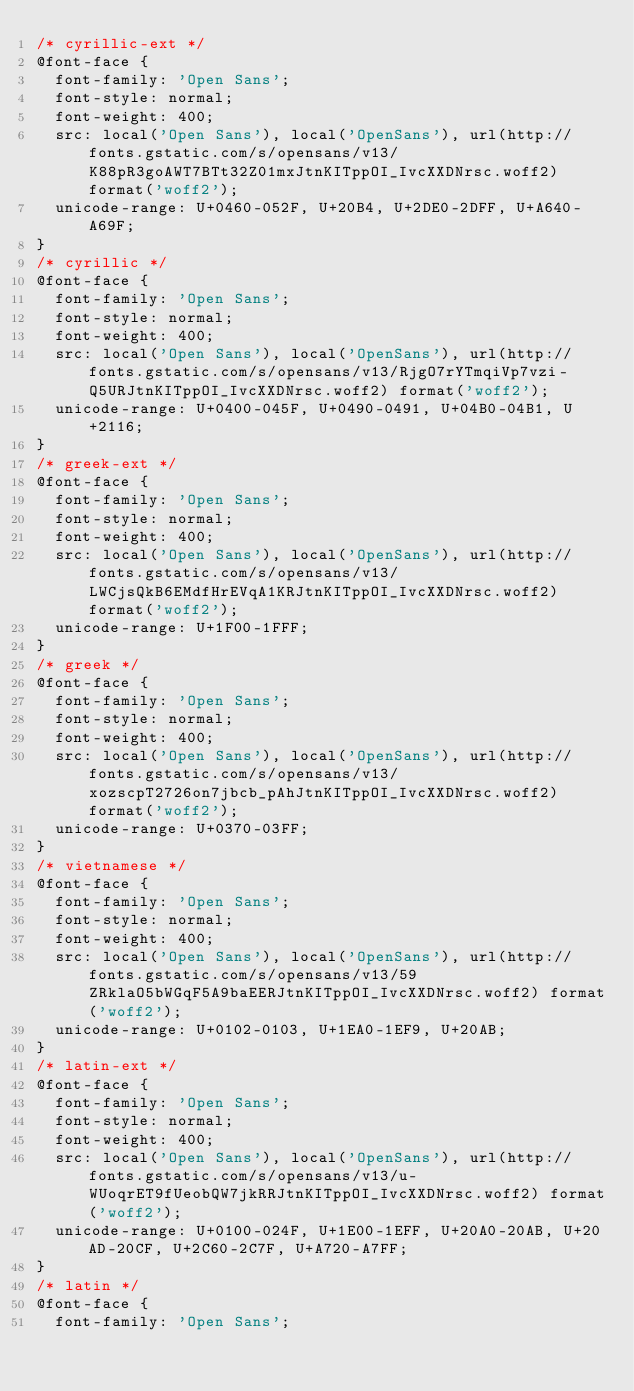Convert code to text. <code><loc_0><loc_0><loc_500><loc_500><_CSS_>/* cyrillic-ext */
@font-face {
  font-family: 'Open Sans';
  font-style: normal;
  font-weight: 400;
  src: local('Open Sans'), local('OpenSans'), url(http://fonts.gstatic.com/s/opensans/v13/K88pR3goAWT7BTt32Z01mxJtnKITppOI_IvcXXDNrsc.woff2) format('woff2');
  unicode-range: U+0460-052F, U+20B4, U+2DE0-2DFF, U+A640-A69F;
}
/* cyrillic */
@font-face {
  font-family: 'Open Sans';
  font-style: normal;
  font-weight: 400;
  src: local('Open Sans'), local('OpenSans'), url(http://fonts.gstatic.com/s/opensans/v13/RjgO7rYTmqiVp7vzi-Q5URJtnKITppOI_IvcXXDNrsc.woff2) format('woff2');
  unicode-range: U+0400-045F, U+0490-0491, U+04B0-04B1, U+2116;
}
/* greek-ext */
@font-face {
  font-family: 'Open Sans';
  font-style: normal;
  font-weight: 400;
  src: local('Open Sans'), local('OpenSans'), url(http://fonts.gstatic.com/s/opensans/v13/LWCjsQkB6EMdfHrEVqA1KRJtnKITppOI_IvcXXDNrsc.woff2) format('woff2');
  unicode-range: U+1F00-1FFF;
}
/* greek */
@font-face {
  font-family: 'Open Sans';
  font-style: normal;
  font-weight: 400;
  src: local('Open Sans'), local('OpenSans'), url(http://fonts.gstatic.com/s/opensans/v13/xozscpT2726on7jbcb_pAhJtnKITppOI_IvcXXDNrsc.woff2) format('woff2');
  unicode-range: U+0370-03FF;
}
/* vietnamese */
@font-face {
  font-family: 'Open Sans';
  font-style: normal;
  font-weight: 400;
  src: local('Open Sans'), local('OpenSans'), url(http://fonts.gstatic.com/s/opensans/v13/59ZRklaO5bWGqF5A9baEERJtnKITppOI_IvcXXDNrsc.woff2) format('woff2');
  unicode-range: U+0102-0103, U+1EA0-1EF9, U+20AB;
}
/* latin-ext */
@font-face {
  font-family: 'Open Sans';
  font-style: normal;
  font-weight: 400;
  src: local('Open Sans'), local('OpenSans'), url(http://fonts.gstatic.com/s/opensans/v13/u-WUoqrET9fUeobQW7jkRRJtnKITppOI_IvcXXDNrsc.woff2) format('woff2');
  unicode-range: U+0100-024F, U+1E00-1EFF, U+20A0-20AB, U+20AD-20CF, U+2C60-2C7F, U+A720-A7FF;
}
/* latin */
@font-face {
  font-family: 'Open Sans';</code> 